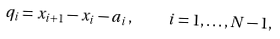<formula> <loc_0><loc_0><loc_500><loc_500>q _ { i } = x _ { i + 1 } - x _ { i } - a _ { i } \, , \quad i = 1 , \dots , N - 1 ,</formula> 